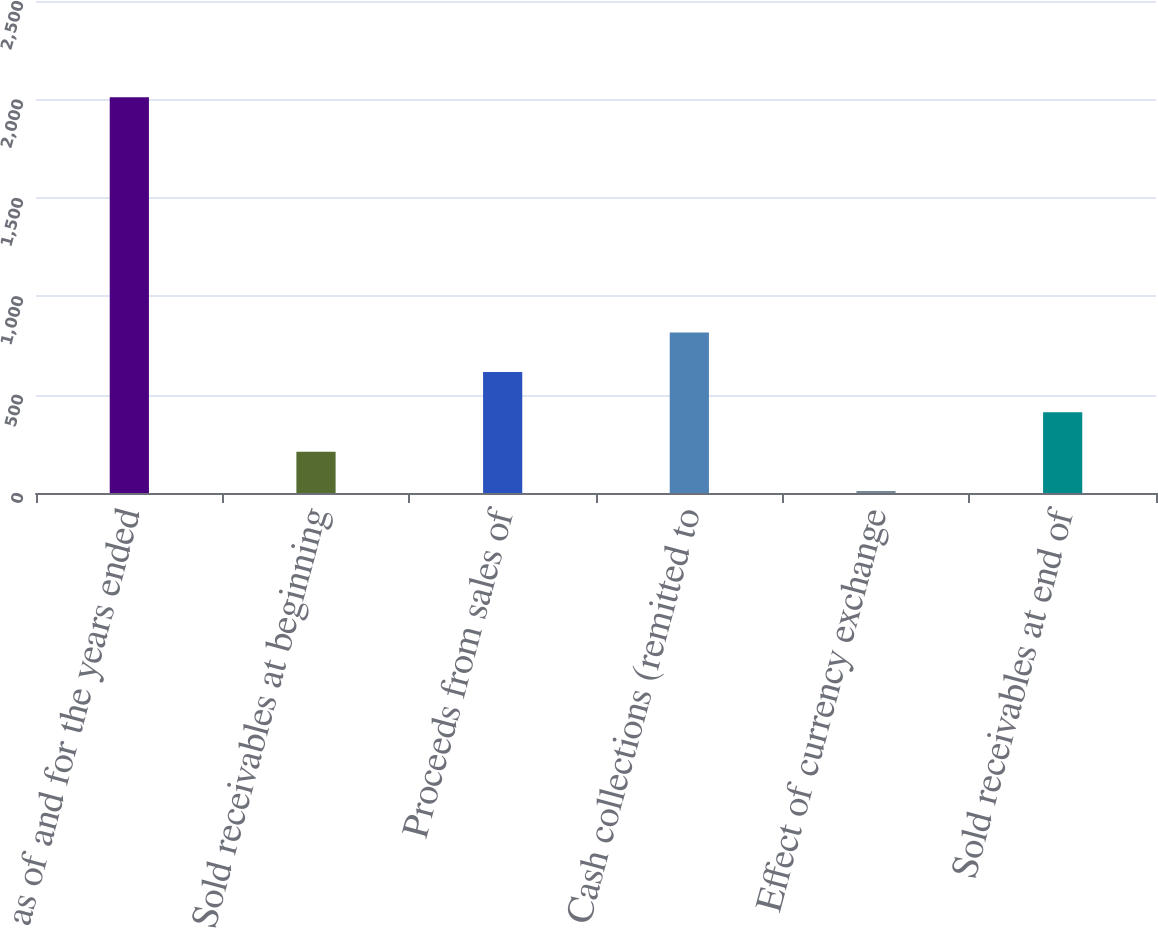<chart> <loc_0><loc_0><loc_500><loc_500><bar_chart><fcel>as of and for the years ended<fcel>Sold receivables at beginning<fcel>Proceeds from sales of<fcel>Cash collections (remitted to<fcel>Effect of currency exchange<fcel>Sold receivables at end of<nl><fcel>2011<fcel>210.1<fcel>615<fcel>815.1<fcel>10<fcel>410.2<nl></chart> 